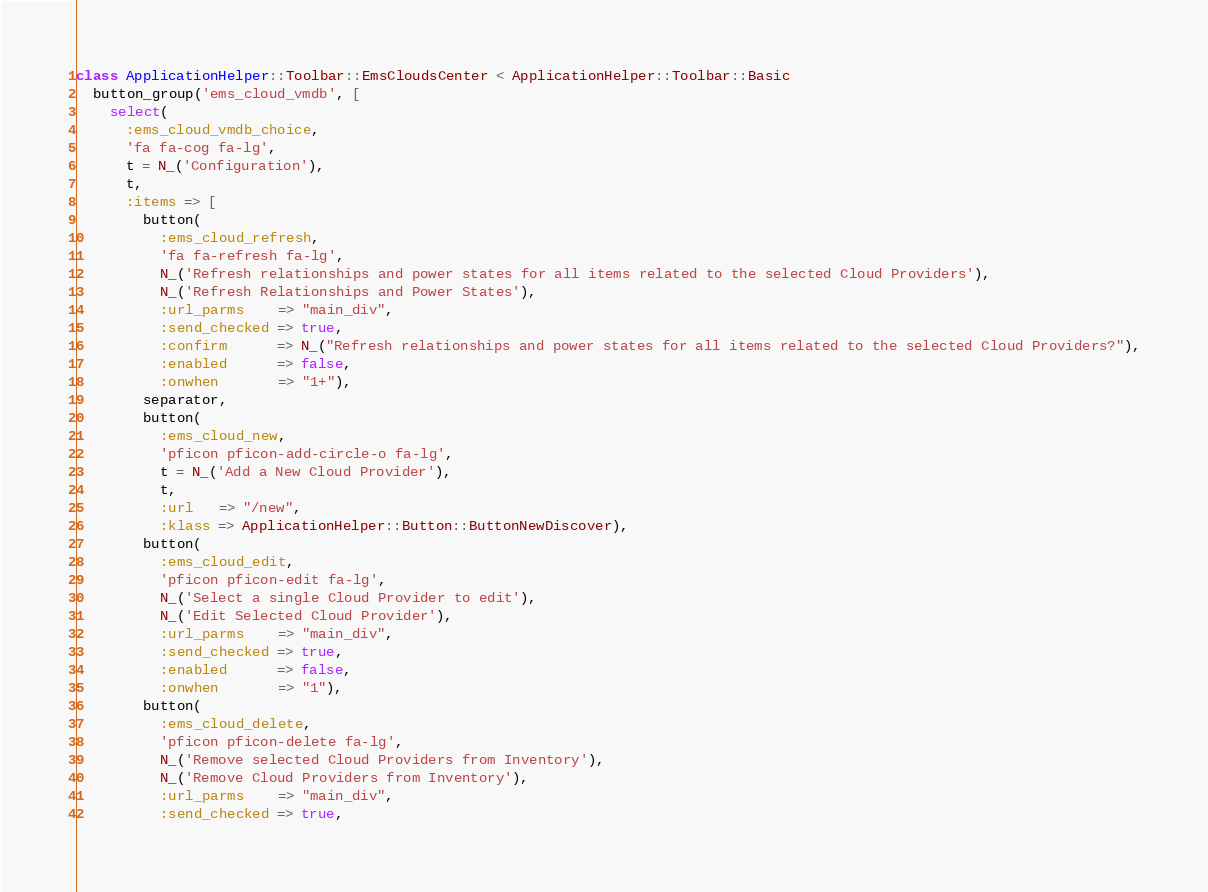Convert code to text. <code><loc_0><loc_0><loc_500><loc_500><_Ruby_>class ApplicationHelper::Toolbar::EmsCloudsCenter < ApplicationHelper::Toolbar::Basic
  button_group('ems_cloud_vmdb', [
    select(
      :ems_cloud_vmdb_choice,
      'fa fa-cog fa-lg',
      t = N_('Configuration'),
      t,
      :items => [
        button(
          :ems_cloud_refresh,
          'fa fa-refresh fa-lg',
          N_('Refresh relationships and power states for all items related to the selected Cloud Providers'),
          N_('Refresh Relationships and Power States'),
          :url_parms    => "main_div",
          :send_checked => true,
          :confirm      => N_("Refresh relationships and power states for all items related to the selected Cloud Providers?"),
          :enabled      => false,
          :onwhen       => "1+"),
        separator,
        button(
          :ems_cloud_new,
          'pficon pficon-add-circle-o fa-lg',
          t = N_('Add a New Cloud Provider'),
          t,
          :url   => "/new",
          :klass => ApplicationHelper::Button::ButtonNewDiscover),
        button(
          :ems_cloud_edit,
          'pficon pficon-edit fa-lg',
          N_('Select a single Cloud Provider to edit'),
          N_('Edit Selected Cloud Provider'),
          :url_parms    => "main_div",
          :send_checked => true,
          :enabled      => false,
          :onwhen       => "1"),
        button(
          :ems_cloud_delete,
          'pficon pficon-delete fa-lg',
          N_('Remove selected Cloud Providers from Inventory'),
          N_('Remove Cloud Providers from Inventory'),
          :url_parms    => "main_div",
          :send_checked => true,</code> 